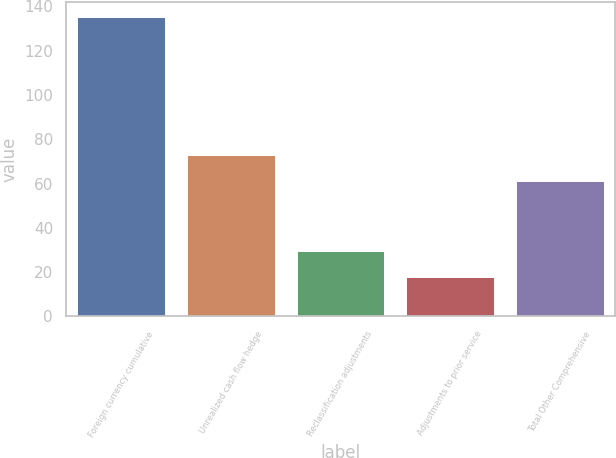<chart> <loc_0><loc_0><loc_500><loc_500><bar_chart><fcel>Foreign currency cumulative<fcel>Unrealized cash flow hedge<fcel>Reclassification adjustments<fcel>Adjustments to prior service<fcel>Total Other Comprehensive<nl><fcel>135.4<fcel>73.07<fcel>29.47<fcel>17.7<fcel>61.3<nl></chart> 